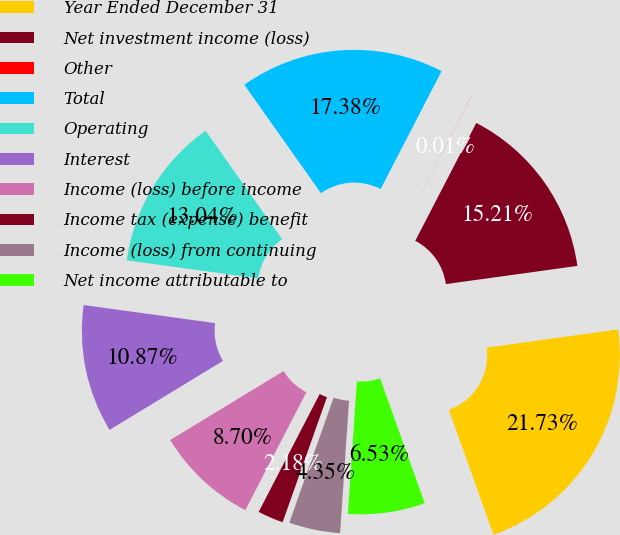Convert chart. <chart><loc_0><loc_0><loc_500><loc_500><pie_chart><fcel>Year Ended December 31<fcel>Net investment income (loss)<fcel>Other<fcel>Total<fcel>Operating<fcel>Interest<fcel>Income (loss) before income<fcel>Income tax (expense) benefit<fcel>Income (loss) from continuing<fcel>Net income attributable to<nl><fcel>21.73%<fcel>15.21%<fcel>0.01%<fcel>17.38%<fcel>13.04%<fcel>10.87%<fcel>8.7%<fcel>2.18%<fcel>4.35%<fcel>6.53%<nl></chart> 